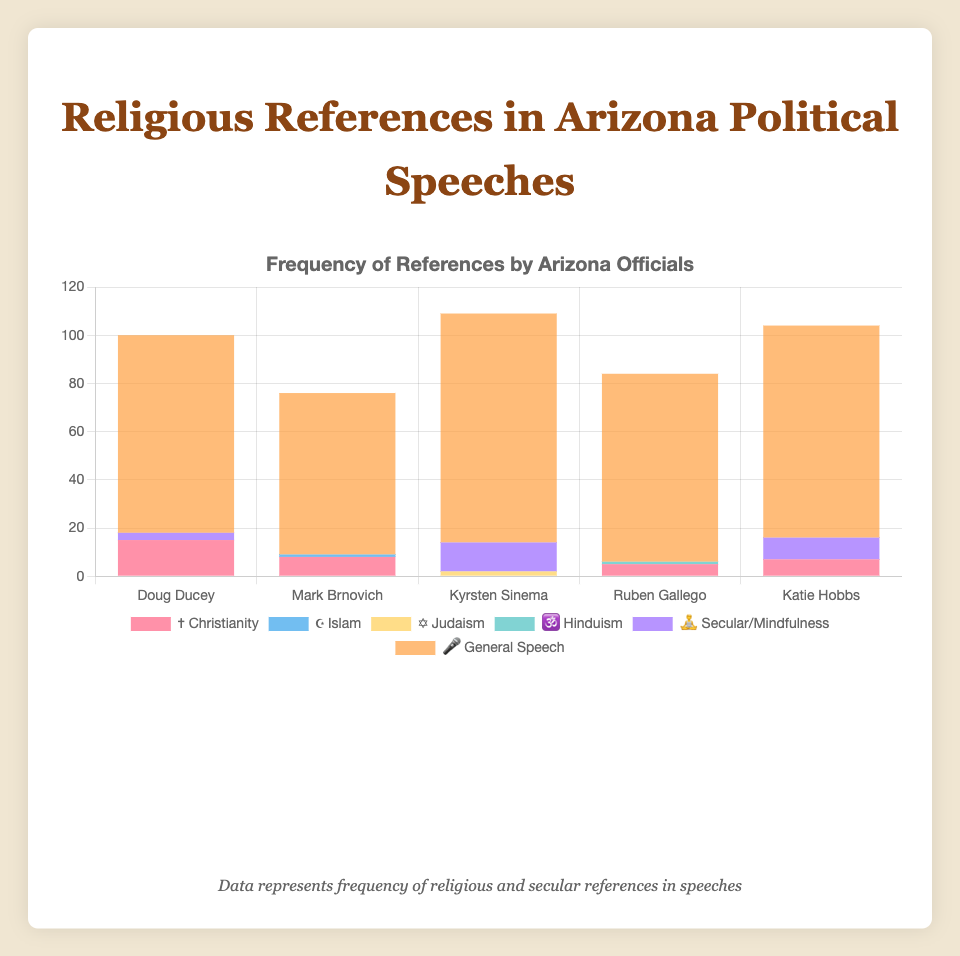What is the title of the chart? The title is found at the top-center of the chart and it summarizes the content of the figure.
Answer: Frequency of References by Arizona Officials How many references to Christianity (✝️) does Doug Ducey have in his speeches? The chart shows the frequency of references by category and official. Locate Doug Ducey along the x-axis and check the value for ✝️ (Christianity).
Answer: 15 Who made the highest number of secular/mindfulness (🧘) references? Examine the y-axis values for secular references (🧘) across all officials and identify the bar with the highest value.
Answer: Kyrsten Sinema What is the total number of general speech (🎤) references made by all officials combined? Sum up the values for general speech references (🎤) for each official and find the total.
Answer: 410 Which official made the least number of references to Islam (☪️)? Identify the references to Islam (☪️) bars in the chart. Since only Mark Brnovich made any references to Islam, others will have the lowest value (0).
Answer: All except Mark Brnovich Compare the references to Hinduism (🕉️) and Judaism (✡️) by Ruben Gallego and Kyrsten Sinema. Look at Ruben Gallego’s and Kyrsten Sinema's bars for 🕉️ Hinduism and ✡️ Judaism and compare the values.
Answer: Ruben Gallego: 1 (🕉️) and 0 (✡️); Kyrsten Sinema: 0 (🕉️) and 2 (✡️) What is the average number of general (🎤) speech references across all officials? Calculate the average by summing the general speech references (🎤) for all officials and dividing by the number of officials.
Answer: 82 Which official made the highest number of references overall? Sum the total references across each category for each official and identify the highest total.
Answer: Kyrsten Sinema (109) How many total references to Christianity (✝️) are there in the chart? Sum the values of references to Christianity (✝️) for all the officials.
Answer: 35 